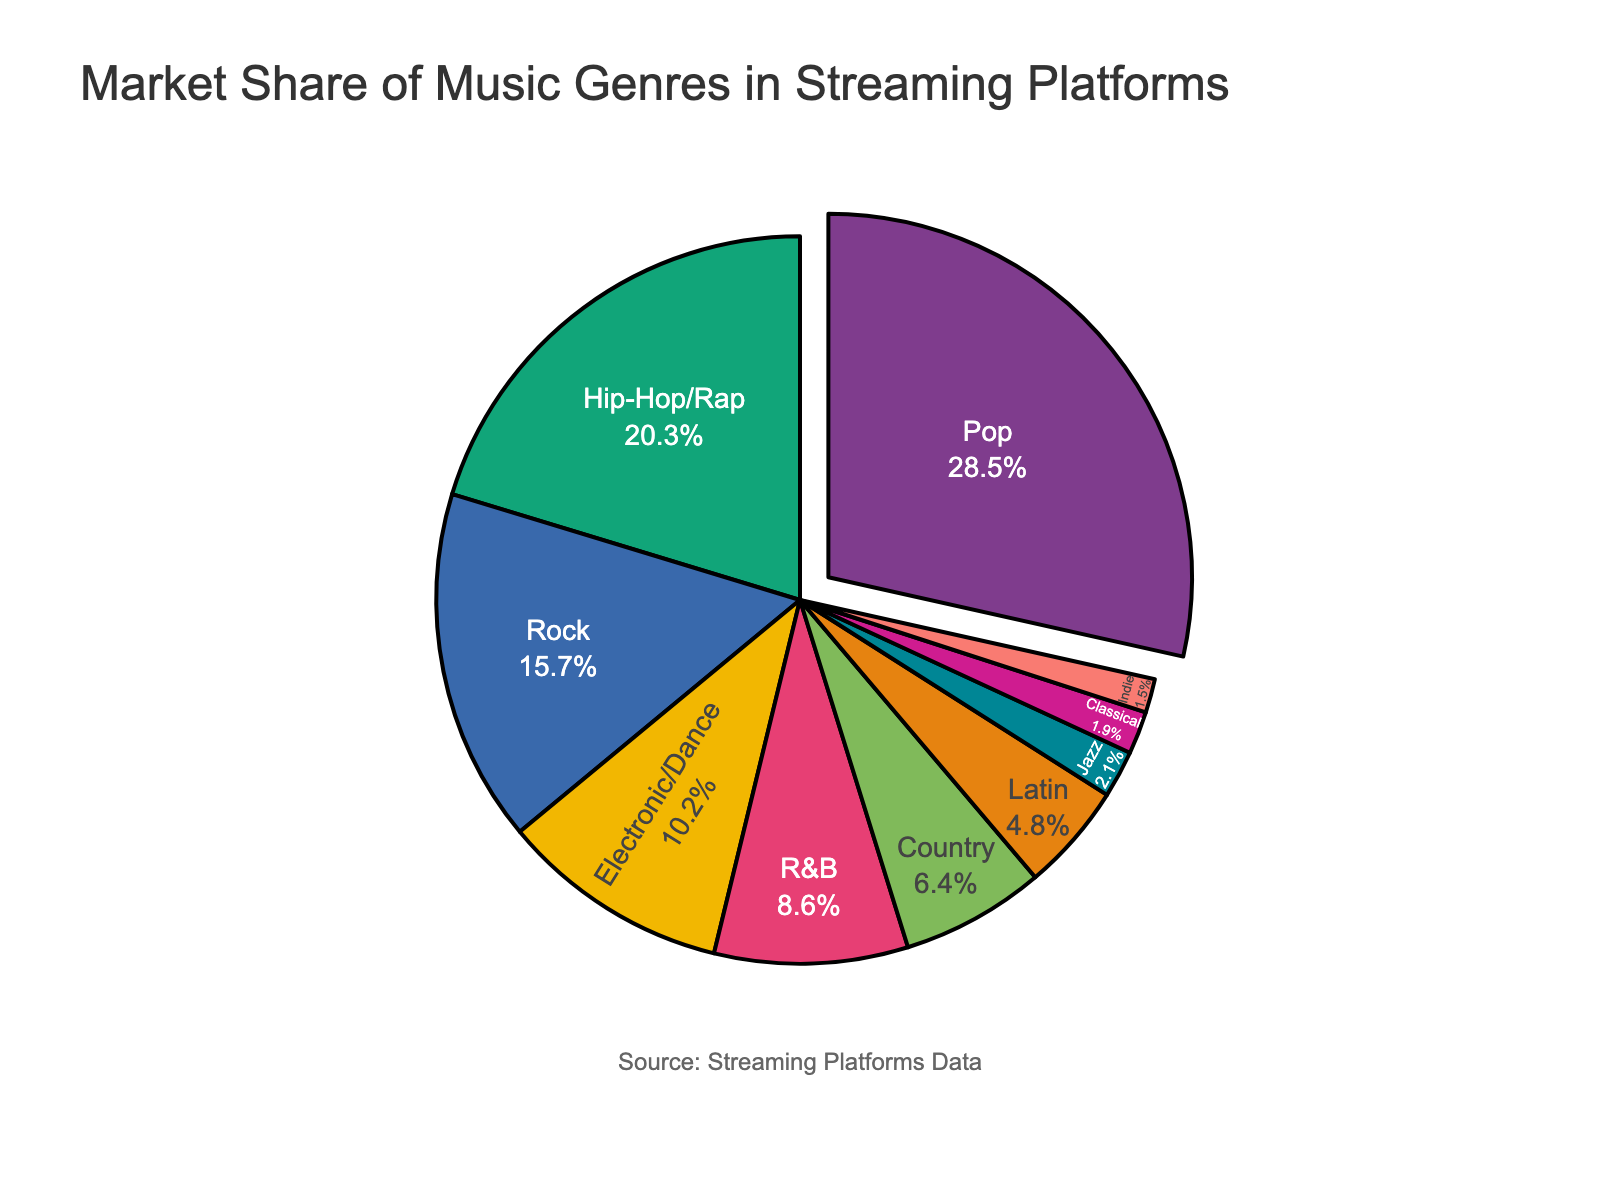What genre has the highest market share in streaming platforms? The pie chart shows various genres with their respective market shares. By visually inspecting the chart, Pop is the largest slice.
Answer: Pop What is the combined market share of Pop and Hip-Hop/Rap? According to the chart, Pop has a market share of 28.5% and Hip-Hop/Rap has 20.3%. Adding these together gives 28.5 + 20.3 = 48.8%.
Answer: 48.8% How much greater is the market share of Rock compared to Jazz? From the pie chart, Rock has a market share of 15.7% and Jazz has 2.1%. Subtracting the two gives 15.7 - 2.1 = 13.6%.
Answer: 13.6% What genres have a market share less than 5%? The chart shows that Latin, Jazz, Classical, and Indie have individual market shares below 5%.
Answer: Latin, Jazz, Classical, Indie Which genre's market share is closest to the average market share of all genres? To find this, first calculate the average market share. The sum of market shares is 100%, and there are 10 genres, so the average is 100% / 10 = 10%. By inspecting the chart, Electronic/Dance is closest with 10.2%.
Answer: Electronic/Dance Is the market share of R&B higher or lower than that of Country, and by how much? The chart lists R&B with 8.6% and Country with 6.4%. R&B is higher than Country. The difference is 8.6% - 6.4% = 2.2%.
Answer: Higher by 2.2% What is the visual indicator used to highlight the genre with the highest market share? The genre with the highest market share, Pop, is visually highlighted by being pulled out slightly from the pie chart.
Answer: Pulled out slice Which genre's market share is nearly half of Pop's market share? Pop has a market share of 28.5%. Nearly half of that is around 14.25%. Rock, with 15.7%, is closest to this value.
Answer: Rock What is the total market share for genres with less than 10% market share each? The genres under 10% are R&B (8.6%), Country (6.4%), Latin (4.8%), Jazz (2.1%), Classical (1.9%), and Indie (1.5%). Their total is 8.6 + 6.4 + 4.8 + 2.1 + 1.9 + 1.5 = 25.3%.
Answer: 25.3% What fraction of the market share does Electronic/Dance hold? Electronic/Dance has a market share of 10.2%. As a fraction of the total 100%, this is 10.2/100, which simplifies to approximately 1/10 (one-tenth).
Answer: 1/10 (one-tenth) 